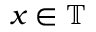<formula> <loc_0><loc_0><loc_500><loc_500>x \in \mathbb { T }</formula> 